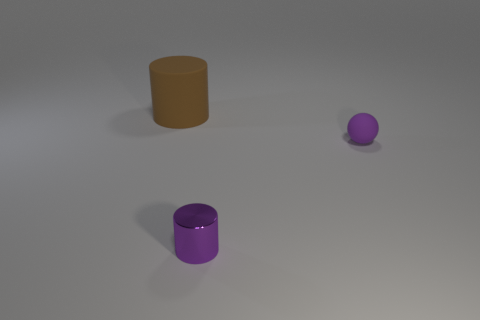There is a matte object on the left side of the matte object in front of the thing that is behind the tiny purple ball; what color is it?
Give a very brief answer. Brown. Is the material of the cylinder on the right side of the brown rubber thing the same as the big brown cylinder?
Give a very brief answer. No. Is there a matte ball that has the same color as the large cylinder?
Provide a short and direct response. No. Are any tiny red shiny things visible?
Offer a very short reply. No. Does the cylinder that is right of the brown thing have the same size as the purple matte thing?
Your response must be concise. Yes. Are there fewer brown matte things than big red rubber things?
Your response must be concise. No. There is a matte object that is on the left side of the cylinder that is in front of the cylinder behind the tiny purple metallic cylinder; what is its shape?
Provide a short and direct response. Cylinder. Is there a tiny thing made of the same material as the purple ball?
Keep it short and to the point. No. Do the matte thing right of the large rubber cylinder and the cylinder on the right side of the big brown object have the same color?
Give a very brief answer. Yes. Are there fewer small purple cylinders that are behind the metal thing than big cyan rubber blocks?
Your answer should be very brief. No. 